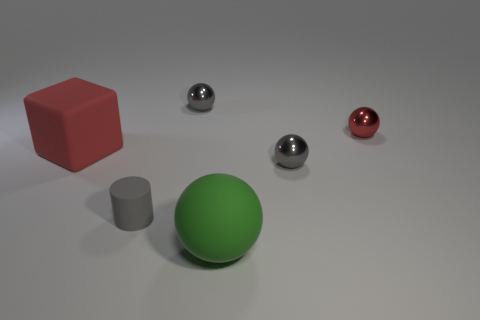What size is the red object on the left side of the matte sphere?
Keep it short and to the point. Large. What number of things are either balls to the left of the tiny red object or tiny objects that are on the right side of the gray rubber thing?
Give a very brief answer. 4. Are there any other things that have the same color as the large block?
Provide a succinct answer. Yes. Is the number of small gray cylinders that are in front of the small gray matte thing the same as the number of rubber blocks that are on the left side of the green thing?
Provide a short and direct response. No. Is the number of tiny gray things behind the red rubber object greater than the number of gray metal blocks?
Ensure brevity in your answer.  Yes. How many things are either tiny gray things behind the small red metal ball or green rubber things?
Offer a very short reply. 2. How many other small gray cylinders have the same material as the small gray cylinder?
Give a very brief answer. 0. There is a small metal object that is the same color as the rubber block; what shape is it?
Give a very brief answer. Sphere. Is there a small blue shiny thing of the same shape as the tiny gray matte thing?
Your answer should be compact. No. What shape is the red shiny thing that is the same size as the gray matte cylinder?
Ensure brevity in your answer.  Sphere. 